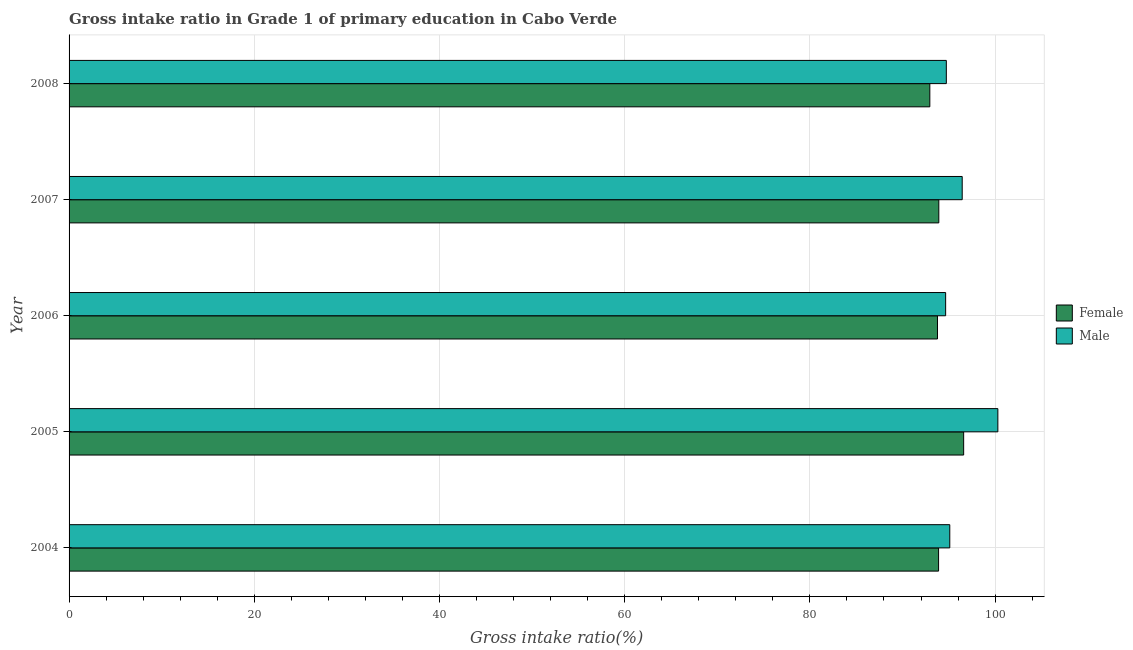How many different coloured bars are there?
Your answer should be very brief. 2. Are the number of bars per tick equal to the number of legend labels?
Give a very brief answer. Yes. What is the label of the 1st group of bars from the top?
Keep it short and to the point. 2008. In how many cases, is the number of bars for a given year not equal to the number of legend labels?
Your answer should be very brief. 0. What is the gross intake ratio(male) in 2007?
Your response must be concise. 96.45. Across all years, what is the maximum gross intake ratio(female)?
Provide a short and direct response. 96.61. Across all years, what is the minimum gross intake ratio(male)?
Your answer should be compact. 94.66. What is the total gross intake ratio(male) in the graph?
Offer a terse response. 481.25. What is the difference between the gross intake ratio(female) in 2004 and that in 2006?
Keep it short and to the point. 0.12. What is the difference between the gross intake ratio(female) in 2005 and the gross intake ratio(male) in 2004?
Provide a short and direct response. 1.5. What is the average gross intake ratio(female) per year?
Ensure brevity in your answer.  94.23. In the year 2007, what is the difference between the gross intake ratio(male) and gross intake ratio(female)?
Offer a terse response. 2.53. Is the difference between the gross intake ratio(male) in 2006 and 2008 greater than the difference between the gross intake ratio(female) in 2006 and 2008?
Your answer should be very brief. No. What is the difference between the highest and the second highest gross intake ratio(male)?
Offer a terse response. 3.85. What is the difference between the highest and the lowest gross intake ratio(male)?
Offer a terse response. 5.64. In how many years, is the gross intake ratio(female) greater than the average gross intake ratio(female) taken over all years?
Your response must be concise. 1. Is the sum of the gross intake ratio(female) in 2005 and 2008 greater than the maximum gross intake ratio(male) across all years?
Provide a succinct answer. Yes. What does the 1st bar from the bottom in 2006 represents?
Your answer should be very brief. Female. How many bars are there?
Provide a short and direct response. 10. How many years are there in the graph?
Give a very brief answer. 5. What is the difference between two consecutive major ticks on the X-axis?
Your answer should be compact. 20. Does the graph contain grids?
Provide a succinct answer. Yes. Where does the legend appear in the graph?
Your answer should be compact. Center right. How are the legend labels stacked?
Provide a succinct answer. Vertical. What is the title of the graph?
Ensure brevity in your answer.  Gross intake ratio in Grade 1 of primary education in Cabo Verde. What is the label or title of the X-axis?
Your response must be concise. Gross intake ratio(%). What is the label or title of the Y-axis?
Give a very brief answer. Year. What is the Gross intake ratio(%) of Female in 2004?
Provide a short and direct response. 93.9. What is the Gross intake ratio(%) in Male in 2004?
Your answer should be very brief. 95.11. What is the Gross intake ratio(%) in Female in 2005?
Give a very brief answer. 96.61. What is the Gross intake ratio(%) in Male in 2005?
Give a very brief answer. 100.3. What is the Gross intake ratio(%) of Female in 2006?
Your answer should be compact. 93.78. What is the Gross intake ratio(%) in Male in 2006?
Provide a succinct answer. 94.66. What is the Gross intake ratio(%) of Female in 2007?
Provide a succinct answer. 93.92. What is the Gross intake ratio(%) in Male in 2007?
Your answer should be compact. 96.45. What is the Gross intake ratio(%) in Female in 2008?
Your answer should be compact. 92.95. What is the Gross intake ratio(%) in Male in 2008?
Make the answer very short. 94.73. Across all years, what is the maximum Gross intake ratio(%) of Female?
Offer a terse response. 96.61. Across all years, what is the maximum Gross intake ratio(%) of Male?
Ensure brevity in your answer.  100.3. Across all years, what is the minimum Gross intake ratio(%) of Female?
Give a very brief answer. 92.95. Across all years, what is the minimum Gross intake ratio(%) in Male?
Offer a very short reply. 94.66. What is the total Gross intake ratio(%) in Female in the graph?
Offer a terse response. 471.16. What is the total Gross intake ratio(%) of Male in the graph?
Your answer should be very brief. 481.25. What is the difference between the Gross intake ratio(%) of Female in 2004 and that in 2005?
Keep it short and to the point. -2.71. What is the difference between the Gross intake ratio(%) of Male in 2004 and that in 2005?
Keep it short and to the point. -5.19. What is the difference between the Gross intake ratio(%) of Female in 2004 and that in 2006?
Offer a terse response. 0.12. What is the difference between the Gross intake ratio(%) in Male in 2004 and that in 2006?
Your response must be concise. 0.45. What is the difference between the Gross intake ratio(%) in Female in 2004 and that in 2007?
Make the answer very short. -0.02. What is the difference between the Gross intake ratio(%) of Male in 2004 and that in 2007?
Your answer should be compact. -1.34. What is the difference between the Gross intake ratio(%) in Female in 2004 and that in 2008?
Your response must be concise. 0.95. What is the difference between the Gross intake ratio(%) of Male in 2004 and that in 2008?
Offer a terse response. 0.37. What is the difference between the Gross intake ratio(%) in Female in 2005 and that in 2006?
Your answer should be very brief. 2.83. What is the difference between the Gross intake ratio(%) in Male in 2005 and that in 2006?
Offer a very short reply. 5.64. What is the difference between the Gross intake ratio(%) of Female in 2005 and that in 2007?
Your response must be concise. 2.68. What is the difference between the Gross intake ratio(%) in Male in 2005 and that in 2007?
Offer a very short reply. 3.85. What is the difference between the Gross intake ratio(%) of Female in 2005 and that in 2008?
Give a very brief answer. 3.65. What is the difference between the Gross intake ratio(%) of Male in 2005 and that in 2008?
Offer a very short reply. 5.57. What is the difference between the Gross intake ratio(%) of Female in 2006 and that in 2007?
Your answer should be very brief. -0.14. What is the difference between the Gross intake ratio(%) in Male in 2006 and that in 2007?
Provide a succinct answer. -1.79. What is the difference between the Gross intake ratio(%) of Female in 2006 and that in 2008?
Your answer should be compact. 0.83. What is the difference between the Gross intake ratio(%) of Male in 2006 and that in 2008?
Offer a terse response. -0.07. What is the difference between the Gross intake ratio(%) of Female in 2007 and that in 2008?
Your response must be concise. 0.97. What is the difference between the Gross intake ratio(%) in Male in 2007 and that in 2008?
Your response must be concise. 1.71. What is the difference between the Gross intake ratio(%) of Female in 2004 and the Gross intake ratio(%) of Male in 2005?
Offer a very short reply. -6.4. What is the difference between the Gross intake ratio(%) of Female in 2004 and the Gross intake ratio(%) of Male in 2006?
Offer a terse response. -0.76. What is the difference between the Gross intake ratio(%) in Female in 2004 and the Gross intake ratio(%) in Male in 2007?
Provide a succinct answer. -2.55. What is the difference between the Gross intake ratio(%) of Female in 2004 and the Gross intake ratio(%) of Male in 2008?
Your response must be concise. -0.84. What is the difference between the Gross intake ratio(%) in Female in 2005 and the Gross intake ratio(%) in Male in 2006?
Ensure brevity in your answer.  1.95. What is the difference between the Gross intake ratio(%) in Female in 2005 and the Gross intake ratio(%) in Male in 2007?
Keep it short and to the point. 0.16. What is the difference between the Gross intake ratio(%) of Female in 2005 and the Gross intake ratio(%) of Male in 2008?
Offer a terse response. 1.87. What is the difference between the Gross intake ratio(%) of Female in 2006 and the Gross intake ratio(%) of Male in 2007?
Ensure brevity in your answer.  -2.67. What is the difference between the Gross intake ratio(%) in Female in 2006 and the Gross intake ratio(%) in Male in 2008?
Offer a terse response. -0.95. What is the difference between the Gross intake ratio(%) of Female in 2007 and the Gross intake ratio(%) of Male in 2008?
Provide a succinct answer. -0.81. What is the average Gross intake ratio(%) in Female per year?
Keep it short and to the point. 94.23. What is the average Gross intake ratio(%) in Male per year?
Offer a terse response. 96.25. In the year 2004, what is the difference between the Gross intake ratio(%) in Female and Gross intake ratio(%) in Male?
Your response must be concise. -1.21. In the year 2005, what is the difference between the Gross intake ratio(%) in Female and Gross intake ratio(%) in Male?
Provide a succinct answer. -3.69. In the year 2006, what is the difference between the Gross intake ratio(%) in Female and Gross intake ratio(%) in Male?
Give a very brief answer. -0.88. In the year 2007, what is the difference between the Gross intake ratio(%) in Female and Gross intake ratio(%) in Male?
Make the answer very short. -2.53. In the year 2008, what is the difference between the Gross intake ratio(%) in Female and Gross intake ratio(%) in Male?
Your response must be concise. -1.78. What is the ratio of the Gross intake ratio(%) of Female in 2004 to that in 2005?
Provide a short and direct response. 0.97. What is the ratio of the Gross intake ratio(%) in Male in 2004 to that in 2005?
Give a very brief answer. 0.95. What is the ratio of the Gross intake ratio(%) of Female in 2004 to that in 2006?
Offer a terse response. 1. What is the ratio of the Gross intake ratio(%) of Male in 2004 to that in 2006?
Give a very brief answer. 1. What is the ratio of the Gross intake ratio(%) of Male in 2004 to that in 2007?
Give a very brief answer. 0.99. What is the ratio of the Gross intake ratio(%) of Female in 2004 to that in 2008?
Make the answer very short. 1.01. What is the ratio of the Gross intake ratio(%) in Male in 2004 to that in 2008?
Offer a terse response. 1. What is the ratio of the Gross intake ratio(%) in Female in 2005 to that in 2006?
Your answer should be compact. 1.03. What is the ratio of the Gross intake ratio(%) in Male in 2005 to that in 2006?
Ensure brevity in your answer.  1.06. What is the ratio of the Gross intake ratio(%) of Female in 2005 to that in 2007?
Your answer should be compact. 1.03. What is the ratio of the Gross intake ratio(%) of Male in 2005 to that in 2007?
Give a very brief answer. 1.04. What is the ratio of the Gross intake ratio(%) in Female in 2005 to that in 2008?
Keep it short and to the point. 1.04. What is the ratio of the Gross intake ratio(%) of Male in 2005 to that in 2008?
Your answer should be compact. 1.06. What is the ratio of the Gross intake ratio(%) of Male in 2006 to that in 2007?
Make the answer very short. 0.98. What is the ratio of the Gross intake ratio(%) of Female in 2006 to that in 2008?
Your response must be concise. 1.01. What is the ratio of the Gross intake ratio(%) of Female in 2007 to that in 2008?
Provide a succinct answer. 1.01. What is the ratio of the Gross intake ratio(%) in Male in 2007 to that in 2008?
Keep it short and to the point. 1.02. What is the difference between the highest and the second highest Gross intake ratio(%) in Female?
Provide a succinct answer. 2.68. What is the difference between the highest and the second highest Gross intake ratio(%) of Male?
Give a very brief answer. 3.85. What is the difference between the highest and the lowest Gross intake ratio(%) in Female?
Offer a very short reply. 3.65. What is the difference between the highest and the lowest Gross intake ratio(%) of Male?
Provide a short and direct response. 5.64. 